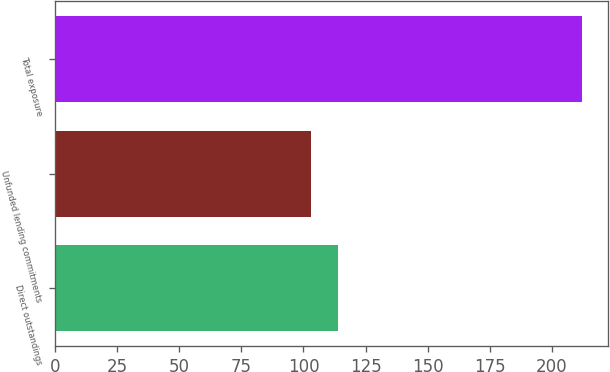Convert chart. <chart><loc_0><loc_0><loc_500><loc_500><bar_chart><fcel>Direct outstandings<fcel>Unfunded lending commitments<fcel>Total exposure<nl><fcel>113.9<fcel>103<fcel>212<nl></chart> 